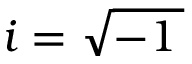Convert formula to latex. <formula><loc_0><loc_0><loc_500><loc_500>i = { \sqrt { - 1 \, } }</formula> 